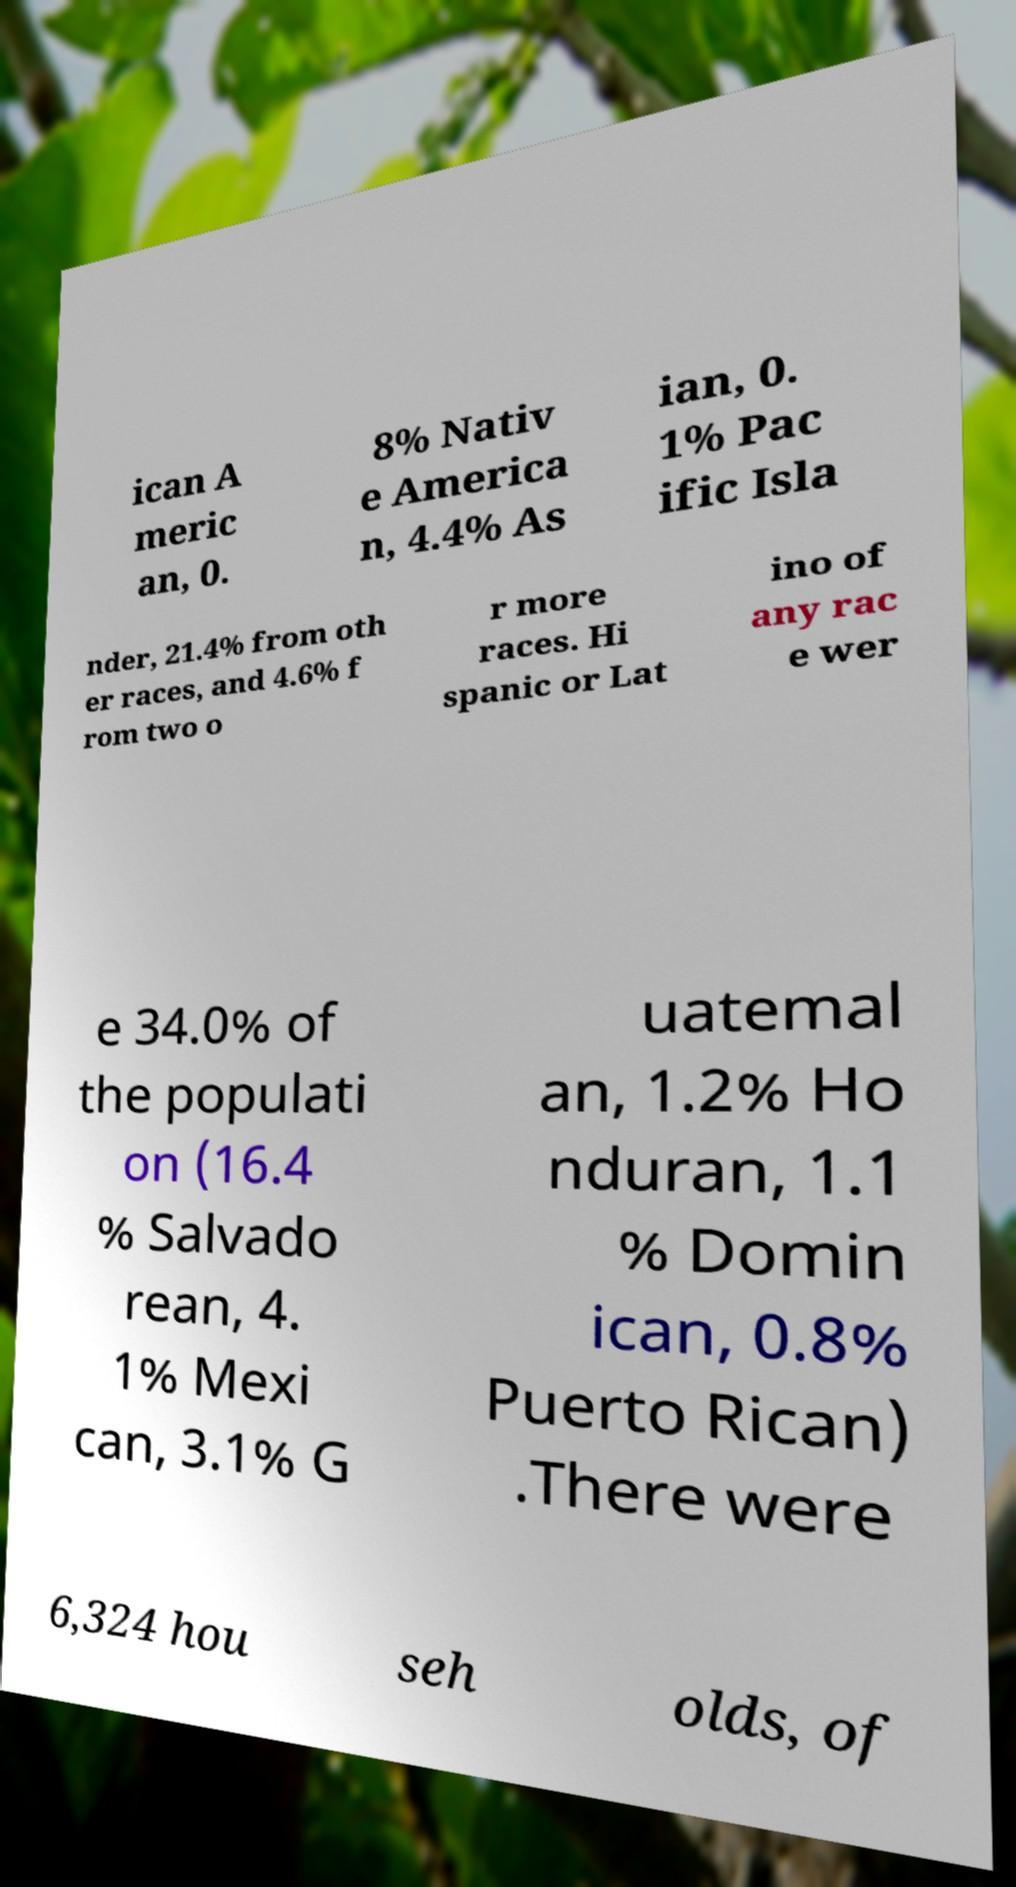Could you extract and type out the text from this image? ican A meric an, 0. 8% Nativ e America n, 4.4% As ian, 0. 1% Pac ific Isla nder, 21.4% from oth er races, and 4.6% f rom two o r more races. Hi spanic or Lat ino of any rac e wer e 34.0% of the populati on (16.4 % Salvado rean, 4. 1% Mexi can, 3.1% G uatemal an, 1.2% Ho nduran, 1.1 % Domin ican, 0.8% Puerto Rican) .There were 6,324 hou seh olds, of 